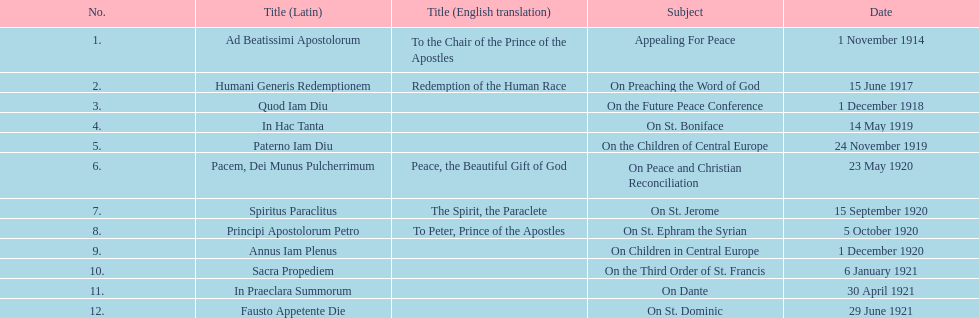What is the title that follows sacra propediem in the list? In Praeclara Summorum. 